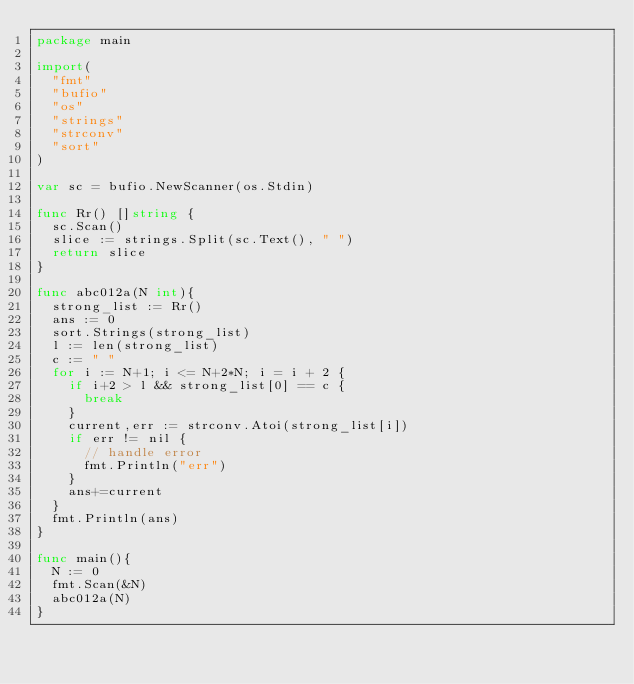Convert code to text. <code><loc_0><loc_0><loc_500><loc_500><_Go_>package main
 
import(
  "fmt"
	"bufio"
	"os"
	"strings"
	"strconv"
	"sort"
)
 
var sc = bufio.NewScanner(os.Stdin)
 
func Rr() []string {
  sc.Scan()
  slice := strings.Split(sc.Text(), " ")
  return slice
}

func abc012a(N int){
	strong_list := Rr()
	ans := 0
	sort.Strings(strong_list)
	l := len(strong_list)	
	c := " "
	for i := N+1; i <= N+2*N; i = i + 2 {
		if i+2 > l && strong_list[0] == c {
			break
		}
		current,err := strconv.Atoi(strong_list[i])
		if err != nil {
      // handle error
      fmt.Println("err")
  	}
		ans+=current
	}
	fmt.Println(ans)
}
 
func main(){
	N := 0
	fmt.Scan(&N)
	abc012a(N)
}</code> 